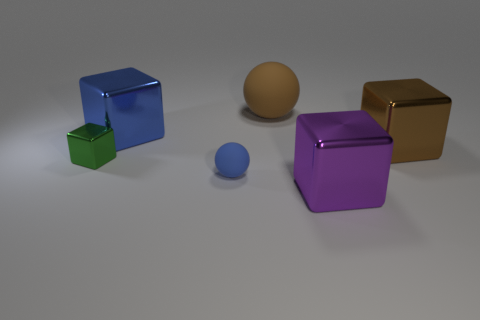Subtract all blue blocks. How many blocks are left? 3 Subtract all blue cubes. How many cubes are left? 3 Add 3 blue spheres. How many objects exist? 9 Subtract 1 cubes. How many cubes are left? 3 Subtract all blocks. How many objects are left? 2 Subtract all green cubes. Subtract all blue cylinders. How many cubes are left? 3 Add 5 tiny blue matte things. How many tiny blue matte things exist? 6 Subtract 0 gray cubes. How many objects are left? 6 Subtract all small green cubes. Subtract all tiny brown metallic balls. How many objects are left? 5 Add 6 blue spheres. How many blue spheres are left? 7 